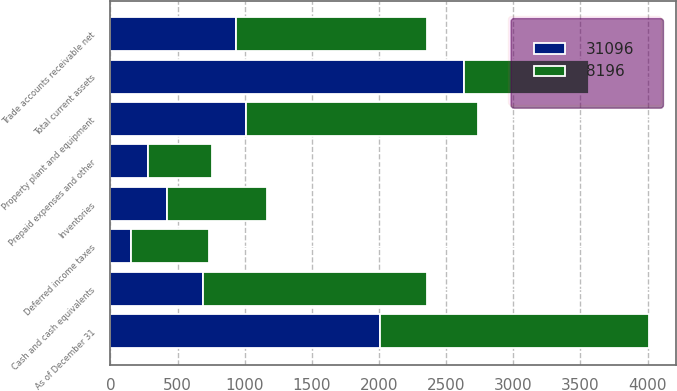Convert chart to OTSL. <chart><loc_0><loc_0><loc_500><loc_500><stacked_bar_chart><ecel><fcel>As of December 31<fcel>Cash and cash equivalents<fcel>Trade accounts receivable net<fcel>Inventories<fcel>Deferred income taxes<fcel>Prepaid expenses and other<fcel>Total current assets<fcel>Property plant and equipment<nl><fcel>8196<fcel>2006<fcel>1668<fcel>1424<fcel>749<fcel>583<fcel>477<fcel>932<fcel>1726<nl><fcel>31096<fcel>2005<fcel>689<fcel>932<fcel>418<fcel>152<fcel>281<fcel>2631<fcel>1011<nl></chart> 